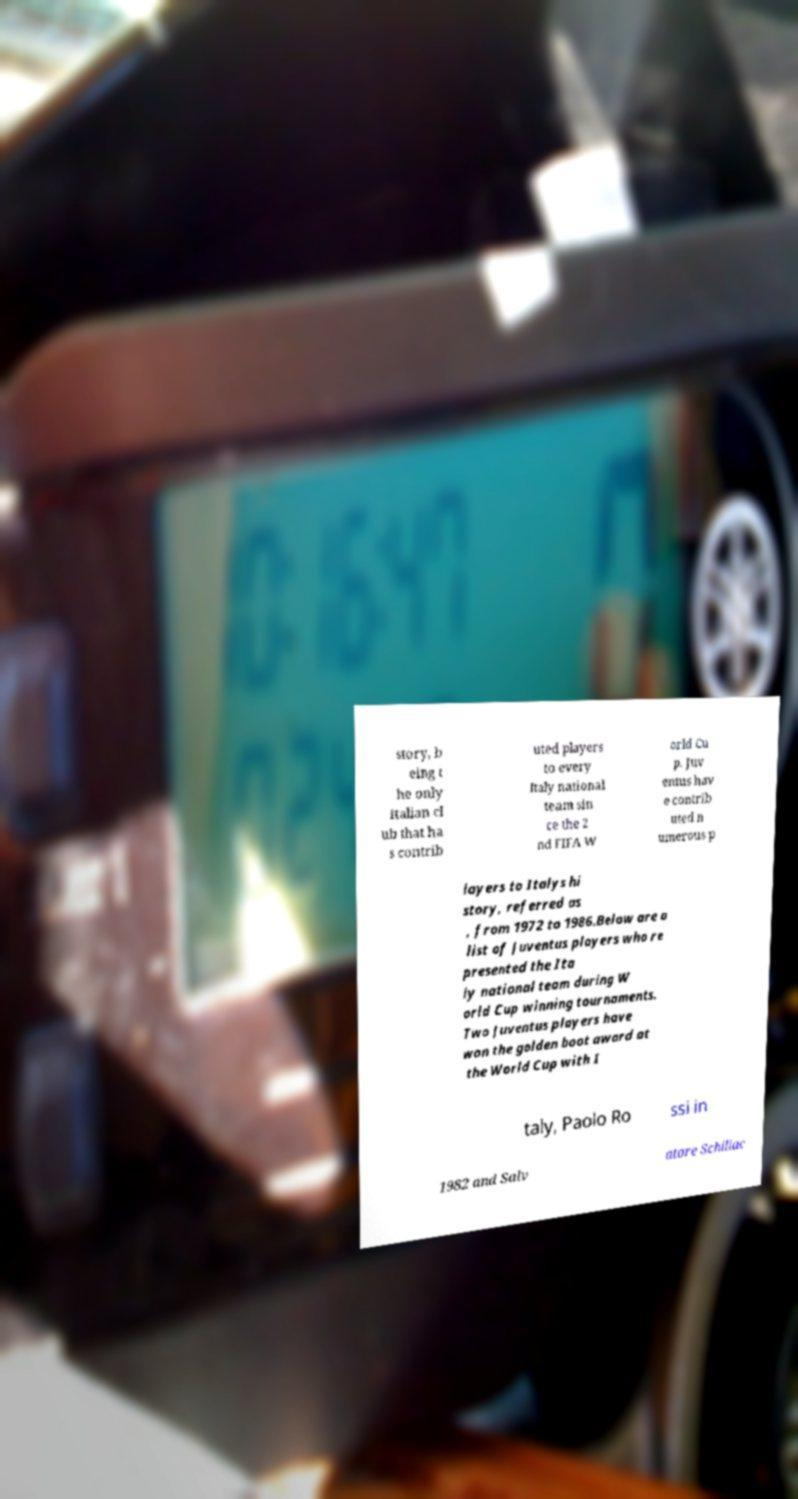Please identify and transcribe the text found in this image. story, b eing t he only Italian cl ub that ha s contrib uted players to every Italy national team sin ce the 2 nd FIFA W orld Cu p. Juv entus hav e contrib uted n umerous p layers to Italys hi story, referred as , from 1972 to 1986.Below are a list of Juventus players who re presented the Ita ly national team during W orld Cup winning tournaments. Two Juventus players have won the golden boot award at the World Cup with I taly, Paolo Ro ssi in 1982 and Salv atore Schillac 